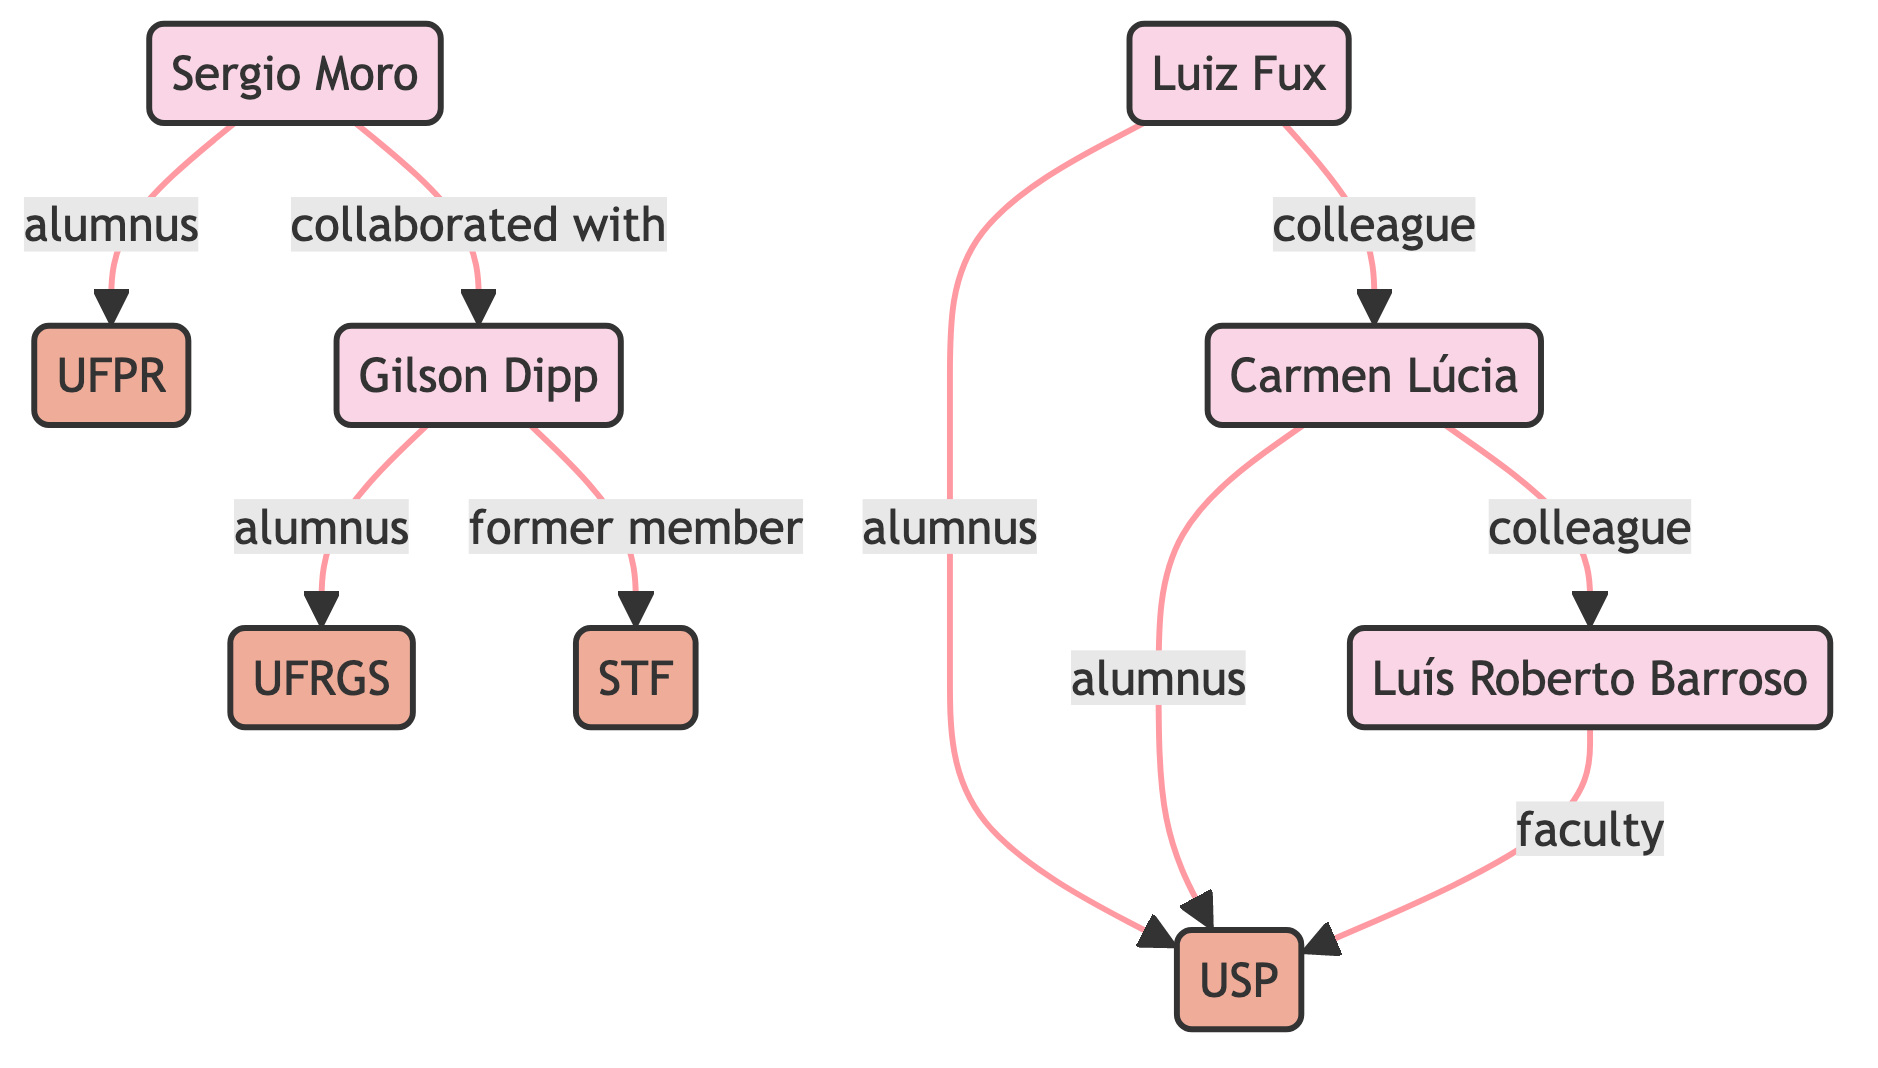What is the total number of scholars in the diagram? The diagram lists five individuals identified as scholars: Gilson Dipp, Sergio Moro, Luiz Fux, Carmen Lúcia, and Luís Roberto Barroso. Counting these nodes gives a total of five scholars.
Answer: 5 How many institutions are represented in the diagram? Reviewing the diagram, there are four institutions: Federal University of Rio Grande do Sul (UFRGS), Federal University of Paraná (UFPR), University of São Paulo (USP), and Supreme Federal Court (STF). Counting these nodes results in four institutions.
Answer: 4 Which institution is Gilson Dipp an alumnus of? The edge connecting Gilson Dipp to UFRGS is labeled "alumnus," indicating his connection as a former student or graduate of that institution. Thus, Gilson Dipp is an alumnus of UFRGS.
Answer: UFRGS Who is Sérgio Moro's academic institution? The edge connecting Sérgio Moro to UFPR is labeled "alumnus," showing that he graduated from this institution. Thus, Sérgio Moro is associated with UFPR.
Answer: UFPR Which two scholars are colleagues according to the diagram? The diagram has an edge labeled "colleague" between Luiz Fux and Carmen Lúcia, indicating that they work together or share a professional relationship. Therefore, the two scholars who are colleagues are Luiz Fux and Carmen Lúcia.
Answer: Luiz Fux and Carmen Lúcia How is Luís Roberto Barroso connected to the University of São Paulo? An edge labeled "faculty" connects Luís Roberto Barroso to USP, indicating his role as a faculty member at that institution, which indicates a professional connection.
Answer: Faculty member What type of relationship does Sérgio Moro have with Gilson Dipp? The edge labeled "collaborated with" links Sérgio Moro and Gilson Dipp. This indicates a collaborative relationship between these two scholars, suggesting they have worked together on some scholarly endeavor.
Answer: Collaborated with Which scholar has been a former member of the Supreme Federal Court? The edge labeled "former member" connects Gilson Dipp to STF, showing that he had a previous position in this institution, indicating his involvement with the Supreme Federal Court.
Answer: Gilson Dipp How many edges connect Gilson Dipp to other nodes in the diagram? Observing the connections for Gilson Dipp, there are three edges: one to UFRGS (alumnus), one to STF (former member), and one to Sergio Moro (collaborated with). Counting these edges gives a total of three connections.
Answer: 3 